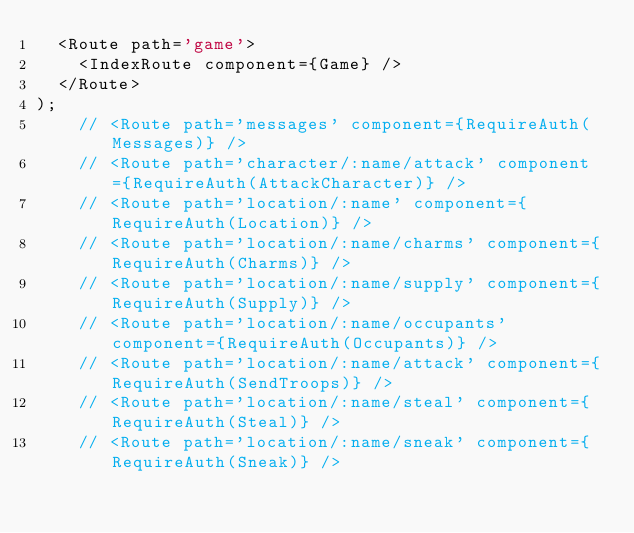<code> <loc_0><loc_0><loc_500><loc_500><_JavaScript_>  <Route path='game'>
    <IndexRoute component={Game} />
  </Route>
);
    // <Route path='messages' component={RequireAuth(Messages)} />
    // <Route path='character/:name/attack' component={RequireAuth(AttackCharacter)} />
    // <Route path='location/:name' component={RequireAuth(Location)} />
    // <Route path='location/:name/charms' component={RequireAuth(Charms)} />
    // <Route path='location/:name/supply' component={RequireAuth(Supply)} />
    // <Route path='location/:name/occupants' component={RequireAuth(Occupants)} />
    // <Route path='location/:name/attack' component={RequireAuth(SendTroops)} />
    // <Route path='location/:name/steal' component={RequireAuth(Steal)} />
    // <Route path='location/:name/sneak' component={RequireAuth(Sneak)} /></code> 